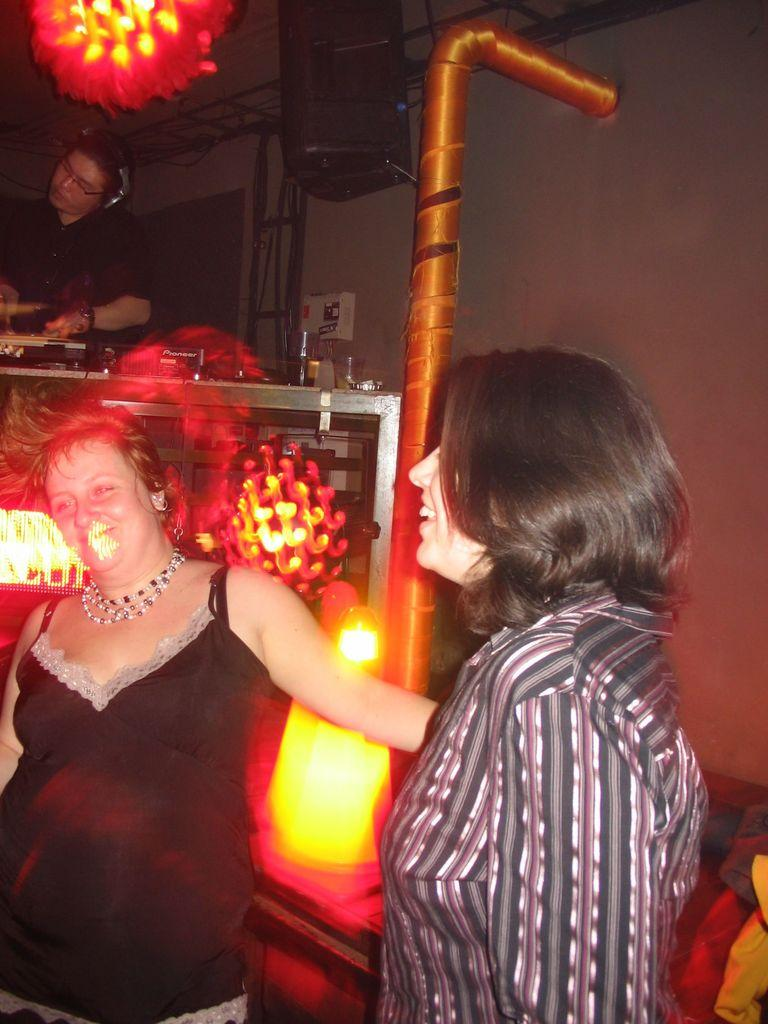What type of establishment is the image taken in? The image appears to be taken inside a bar. What are the two women in the front of the image doing? The two women in the front of the image are dancing. What is the person in the back of the image wearing? The person in the back of the image is wearing headphones. What can be seen above the ceiling in the image? There are lights visible over the ceiling in the image. What shape is the point of the cellar in the image? There is no point or cellar present in the image. How many people are forming a circle in the image? There are no people forming a circle in the image. 